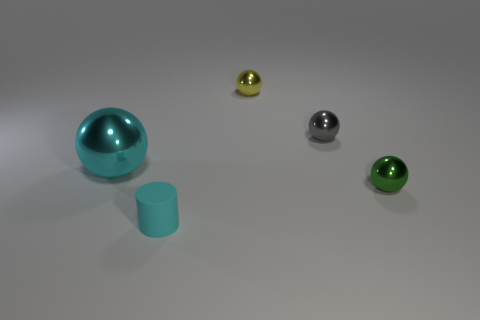Subtract 1 balls. How many balls are left? 3 Subtract all blue balls. Subtract all yellow cubes. How many balls are left? 4 Add 5 large cyan cubes. How many objects exist? 10 Subtract all cylinders. How many objects are left? 4 Subtract all gray spheres. Subtract all cyan matte cylinders. How many objects are left? 3 Add 5 small green things. How many small green things are left? 6 Add 3 small metal objects. How many small metal objects exist? 6 Subtract 0 red cubes. How many objects are left? 5 